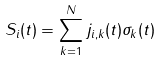Convert formula to latex. <formula><loc_0><loc_0><loc_500><loc_500>S _ { i } ( t ) = \sum _ { k = 1 } ^ { N } j _ { i , k } ( t ) \sigma _ { k } ( t )</formula> 